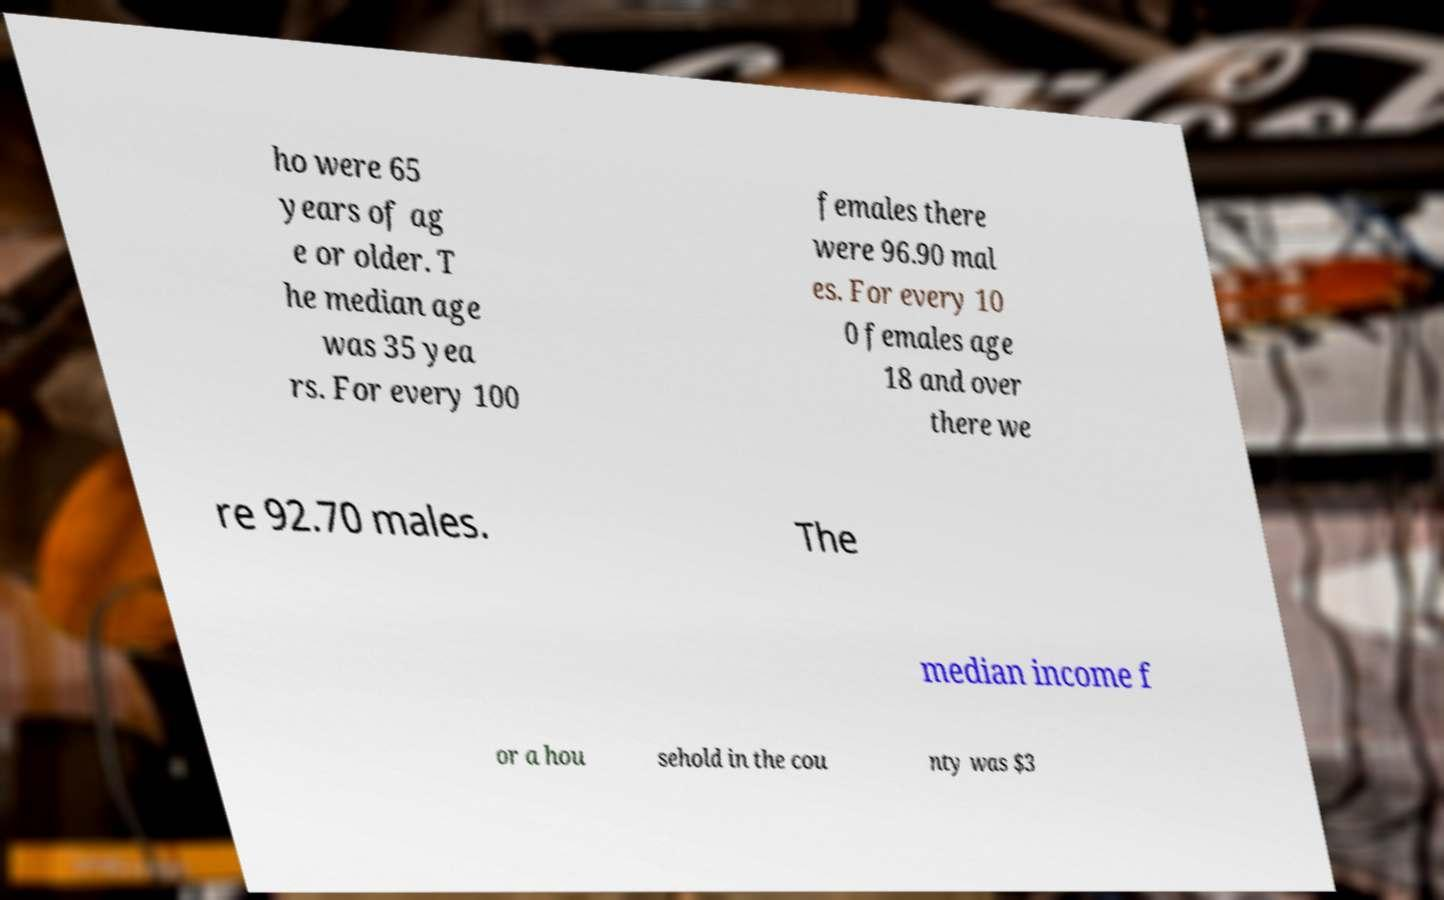Could you extract and type out the text from this image? ho were 65 years of ag e or older. T he median age was 35 yea rs. For every 100 females there were 96.90 mal es. For every 10 0 females age 18 and over there we re 92.70 males. The median income f or a hou sehold in the cou nty was $3 